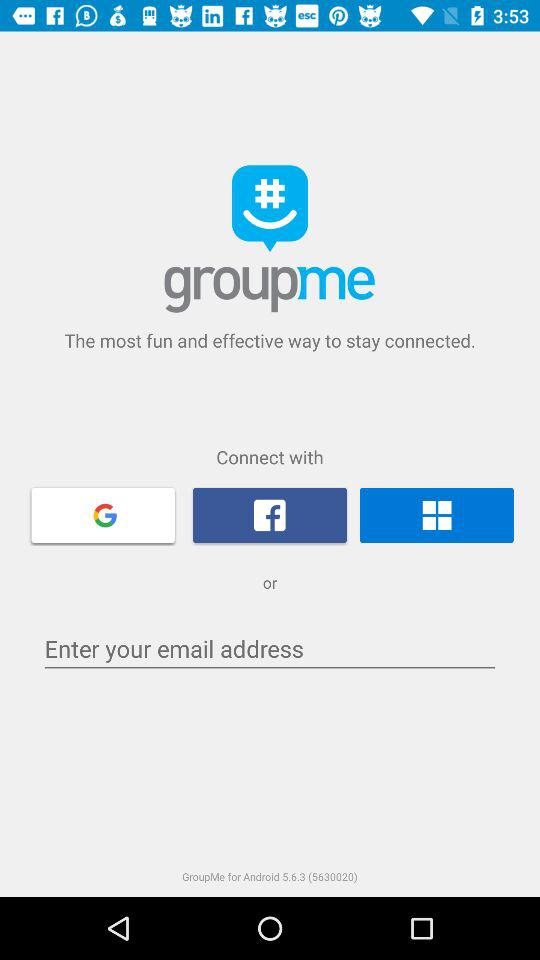Through which applications can we connect? You can connect through "Google", "Facebook" and "Windows". 